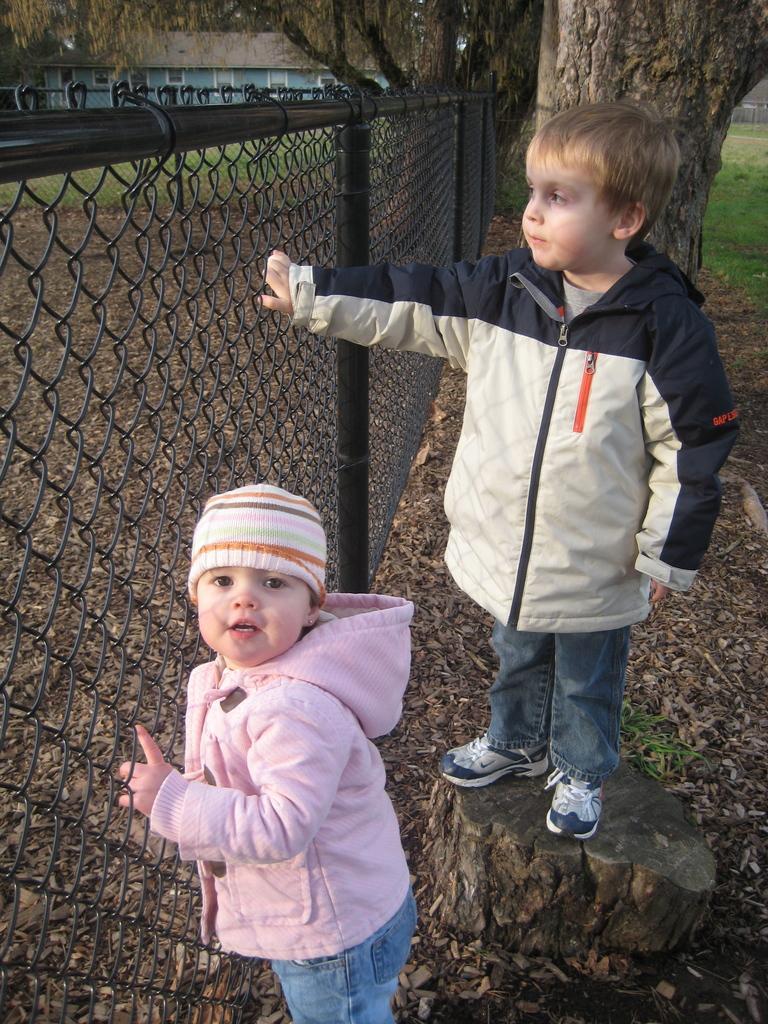Describe this image in one or two sentences. In this picture we can see two kids wearing jacket standing near the fencing and in the background of the picture there are some trees, houses and top of the picture there is clear sky. 